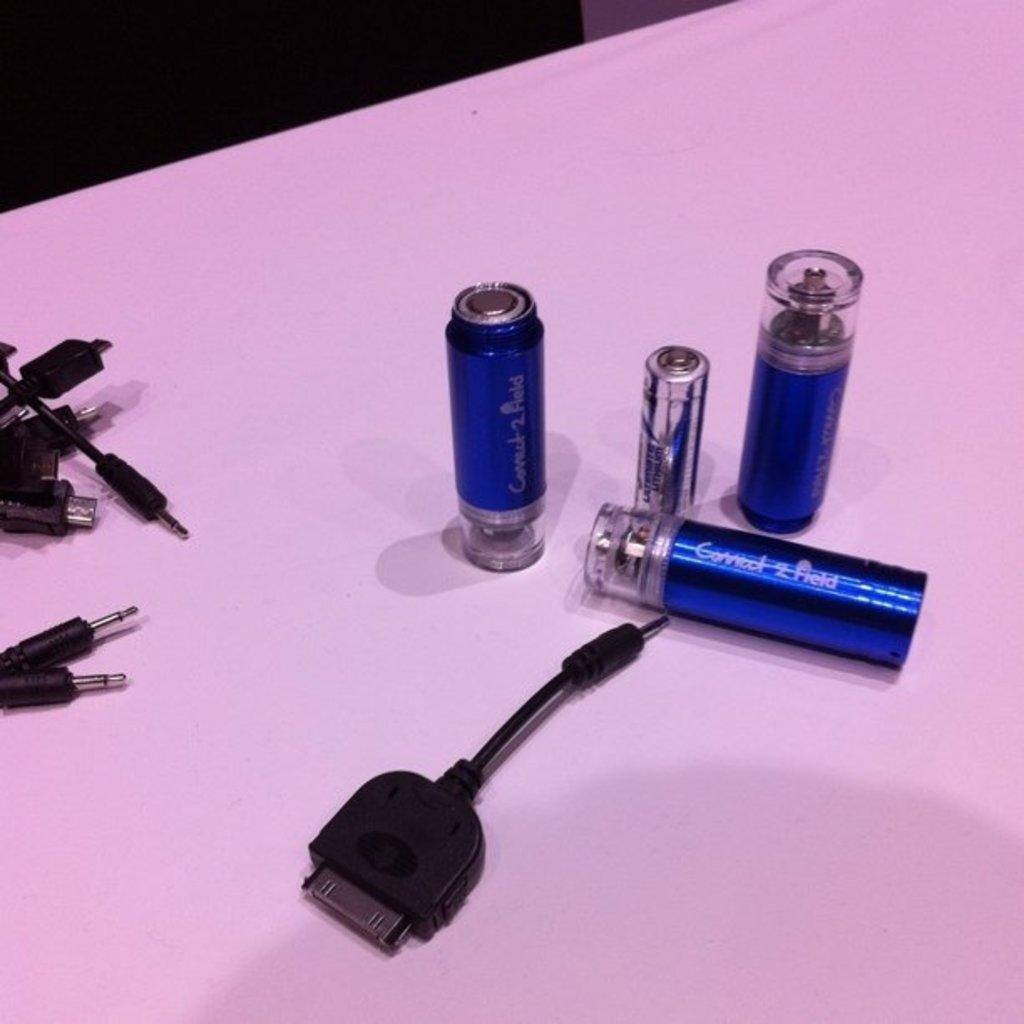<image>
Present a compact description of the photo's key features. Different components sit on a surface with one reading connect 2 field. 